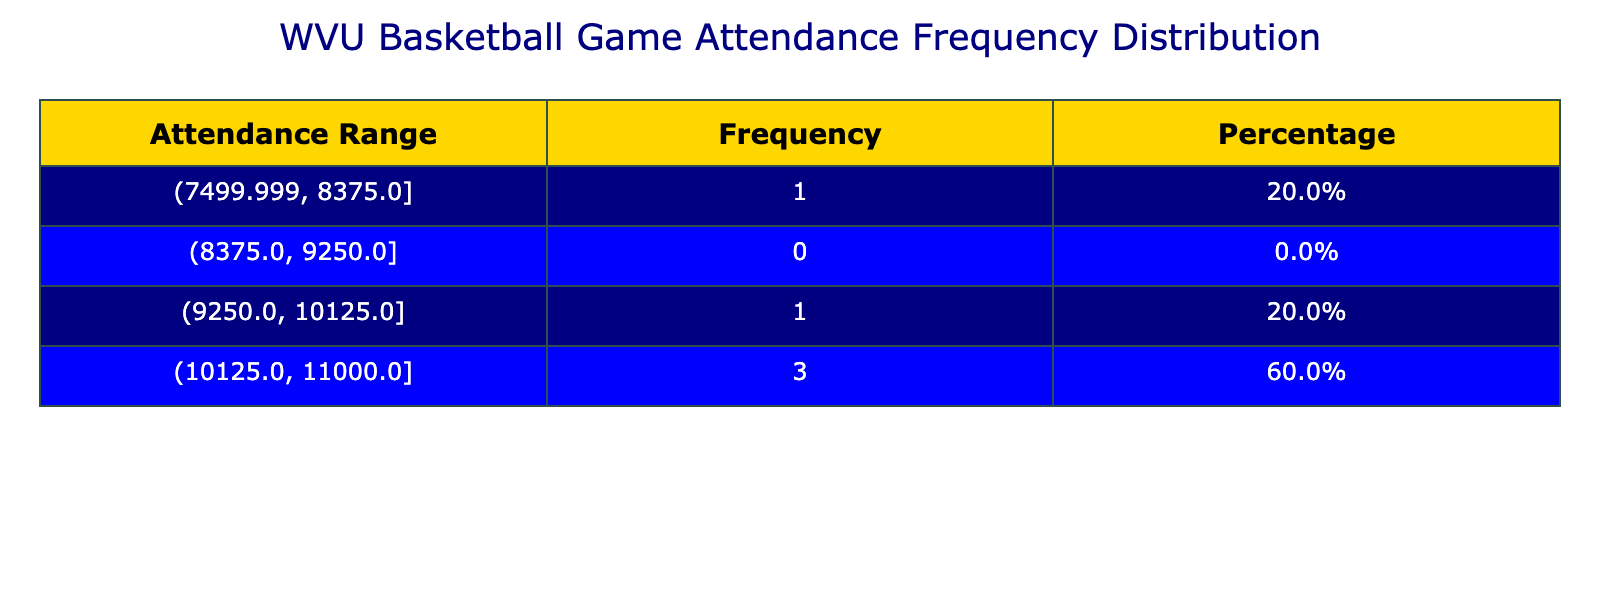What is the average attendance for the 2022-2023 season? From the table, the average attendance for the 2022-2023 season is directly listed as 11000.
Answer: 11000 How many seasons had an average attendance greater than 10000? By checking the attendance values, I see that two seasons (2019-2020 and 2022-2023) have averages above 10000.
Answer: 2 Was the average attendance for the 2020-2021 season lower than 9000? The table shows an average attendance of 7500 for the 2020-2021 season, which is indeed lower than 9000.
Answer: Yes What is the percentage of seasons that had an average attendance of 9500 or more? There are 5 seasons total, and 3 of them (2019-2020, 2021-2022, and 2022-2023) had an average attendance of 9500 or more. The percentage is (3/5) * 100 = 60%.
Answer: 60% What is the average attendance of all listed seasons? To find the average attendance, I sum the values: 10318 + 10523 + 7500 + 9500 + 11000 = 49341, and then divide by 5, which gives me 9868.2.
Answer: 9868.2 If we exclude the season with the lowest average attendance, what is the new average attendance? The lowest average attendance is 7500 from the 2020-2021 season. Excluding it, we have 4 seasons: 10318, 10523, 9500, and 11000. The sum is 10318 + 10523 + 9500 + 11000 = 41341, and the new average is 41341 / 4 = 10335.25.
Answer: 10335.25 Which season had the highest average attendance? The table shows that the highest average attendance is 11000 for the 2022-2023 season.
Answer: 2022-2023 How does the average attendance in the 2021-2022 season compare to the previous season? The 2021-2022 season had an average attendance of 9500, while the previous season (2020-2021) had 7500. The comparison shows that 9500 is greater than 7500.
Answer: Higher What is the difference in average attendance between the seasons with the highest and lowest attendance? The highest attendance is 11000 (2022-2023) and the lowest is 7500 (2020-2021). The difference is 11000 - 7500 = 3500.
Answer: 3500 